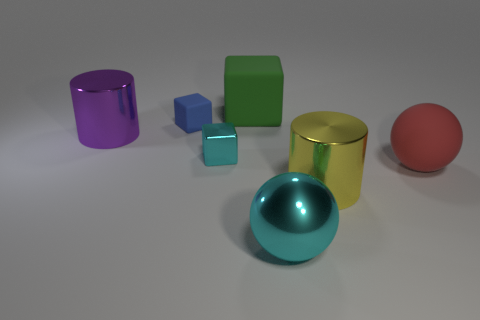Subtract all cyan metal blocks. How many blocks are left? 2 Add 1 metallic spheres. How many objects exist? 8 Subtract all cyan cubes. How many cubes are left? 2 Subtract all cyan blocks. How many yellow spheres are left? 0 Subtract 1 cubes. How many cubes are left? 2 Subtract all large red matte objects. Subtract all red matte things. How many objects are left? 5 Add 7 red balls. How many red balls are left? 8 Add 7 large green rubber objects. How many large green rubber objects exist? 8 Subtract 0 brown spheres. How many objects are left? 7 Subtract all balls. How many objects are left? 5 